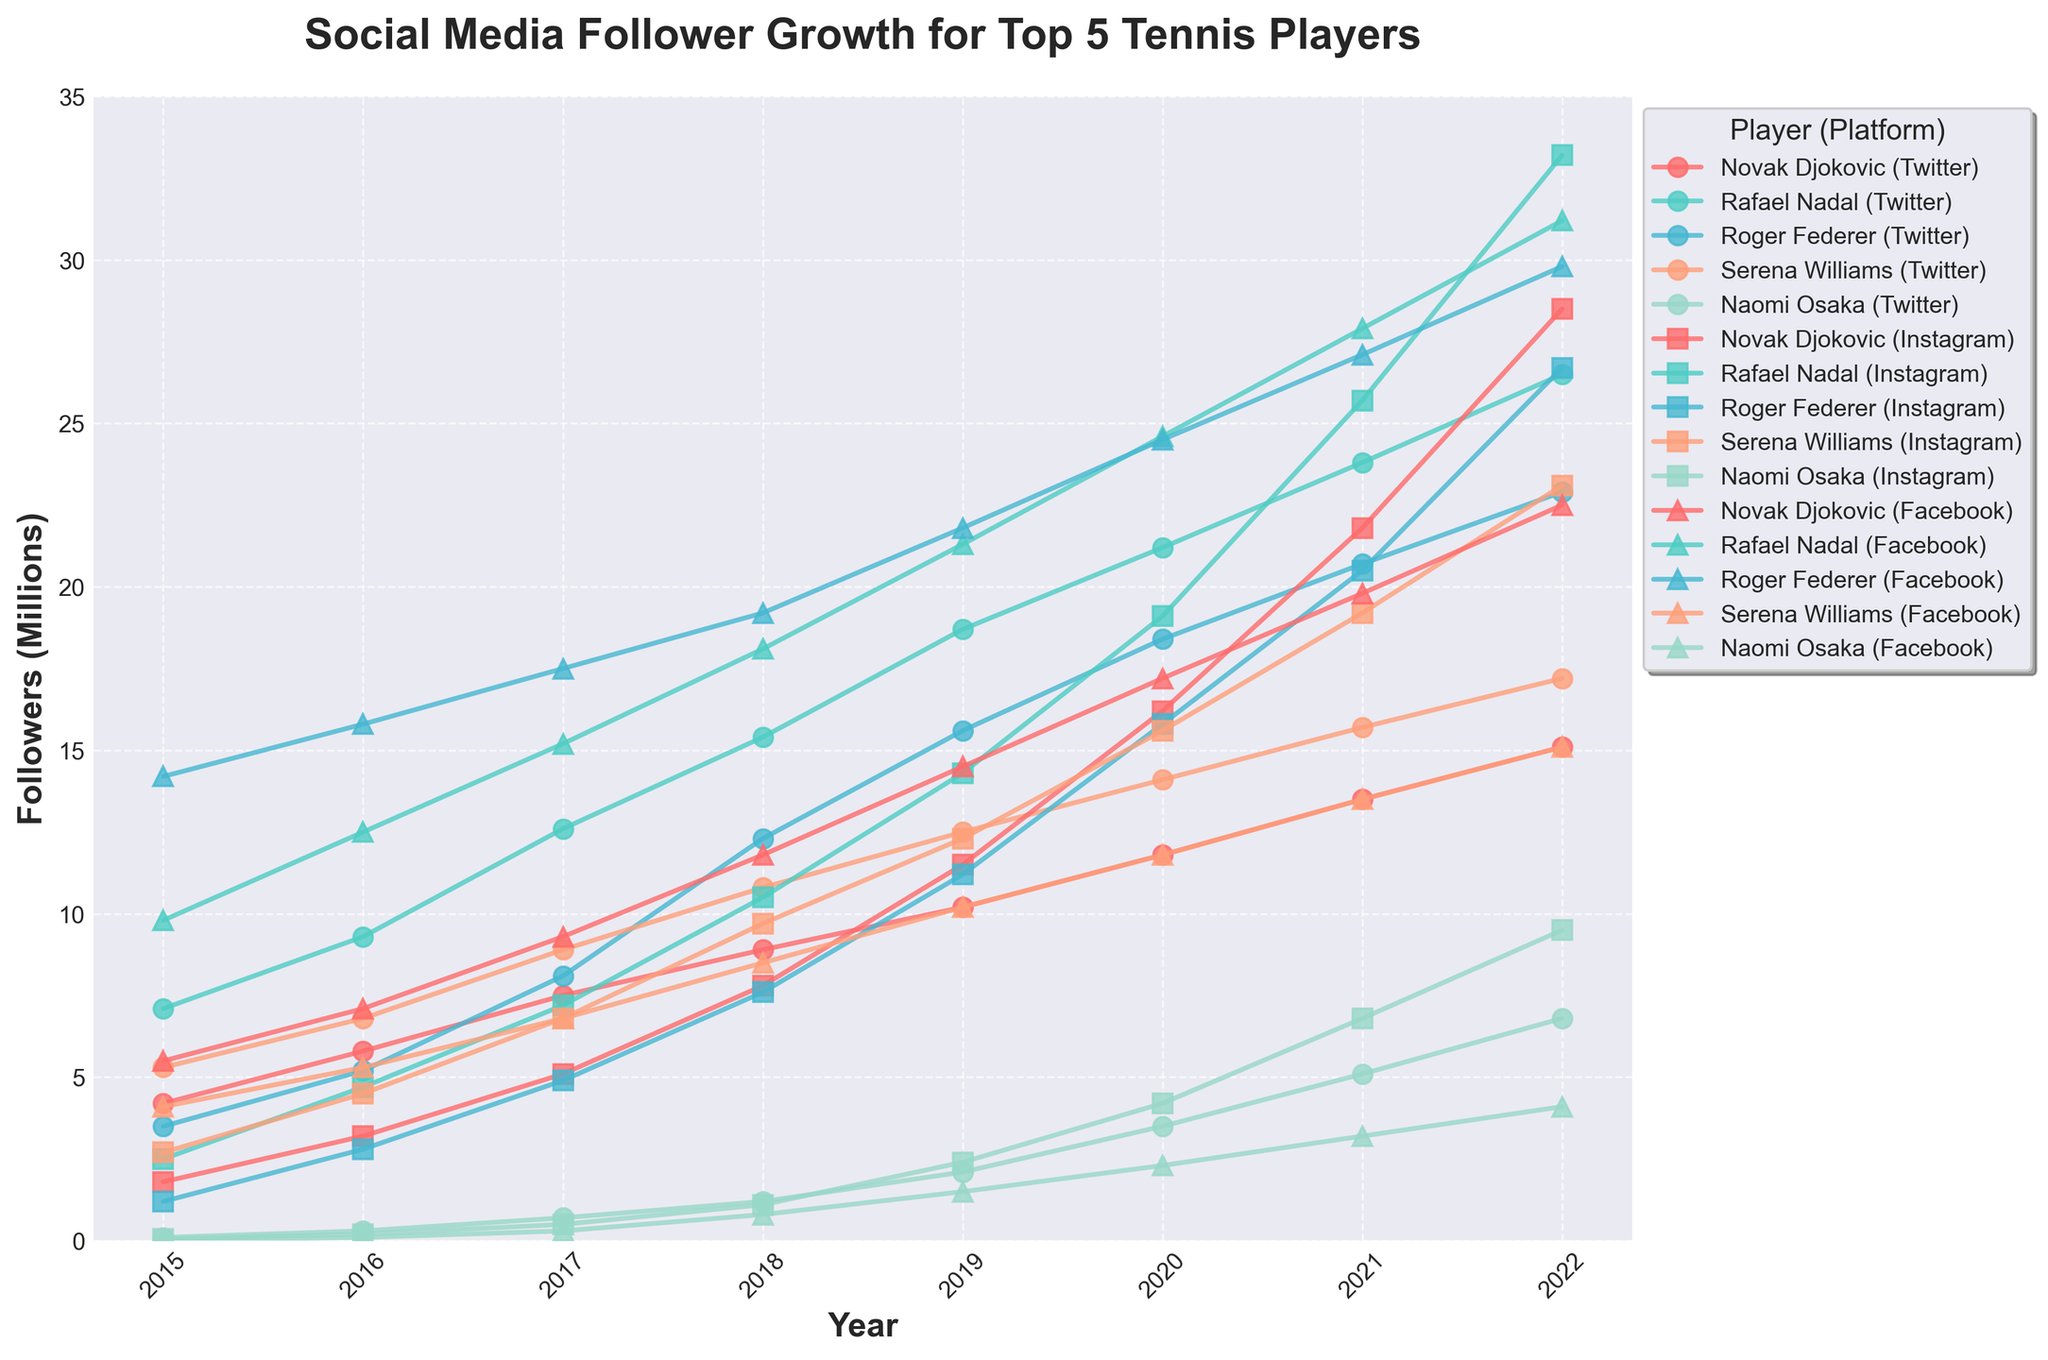Which player's Instagram followers grew the fastest from 2015 to 2022? By analyzing the lines representing Instagram follower growth, Naomi Osaka's line shows the steepest increase from 0.05 million in 2015 to 9.5 million in 2022, indicating the fastest growth.
Answer: Naomi Osaka Who had more Twitter followers in 2020, Serena Williams or Roger Federer? By locating the Twitter data points for 2020, Roger Federer had about 18.4 million followers, while Serena Williams had about 14.1 million. Roger Federer had more followers.
Answer: Roger Federer Compare the Instagram followers of Novak Djokovic and Rafael Nadal in 2021. Who had more? Checking the Instagram lines for 2021, Novak Djokovic had approximately 21.8 million followers, whereas Rafael Nadal had about 25.7 million, so Rafael Nadal had more Instagram followers in 2021.
Answer: Rafael Nadal What is the combined number of Facebook followers for all five players in 2019? Adding the Facebook followers for all five players in 2019: Novak Djokovic (14.5M), Rafael Nadal (21.3M), Roger Federer (21.8M), Serena Williams (10.2M), and Naomi Osaka (1.5M). The total is 69.3 million.
Answer: 69.3 million Which player had the highest total followers across all platforms in 2017? Summing the followers across Twitter, Instagram, and Facebook for each player in 2017 and comparing the totals: Novak Djokovic (7.5+5.1+9.3=21.9M), Rafael Nadal (12.6+7.2+15.2=35M), Roger Federer (8.1+4.9+17.5=30.5M), Serena Williams (8.9+6.8+6.8=22.5M), Naomi Osaka (0.7+0.5+0.3=1.5M). Rafael Nadal had the highest total.
Answer: Rafael Nadal What is the difference in Instagram followers between Naomi Osaka and Serena Williams in 2022? In 2022, Naomi Osaka had 9.5 million Instagram followers while Serena Williams had 23.1 million. The difference is 23.1 - 9.5 = 13.6 million.
Answer: 13.6 million How did the growth of Rafael Nadal's Twitter followers from 2015 to 2022 compare to Roger Federer's? Rafael Nadal's Twitter followers grew from 7.1M in 2015 to 26.5M in 2022 (a 19.4M increase). Roger Federer's grew from 3.5M in 2015 to 22.9M in 2022 (a 19.4M increase). Both players had the same increase.
Answer: Same Which platform had the smallest increase in followers for Novak Djokovic from 2015 to 2022? Comparing the increase across platforms: Twitter (4.2M to 15.1M), Instagram (1.8M to 28.5M), and Facebook (5.5M to 22.5M). The smallest increase is Twitter: 10.9M.
Answer: Twitter 